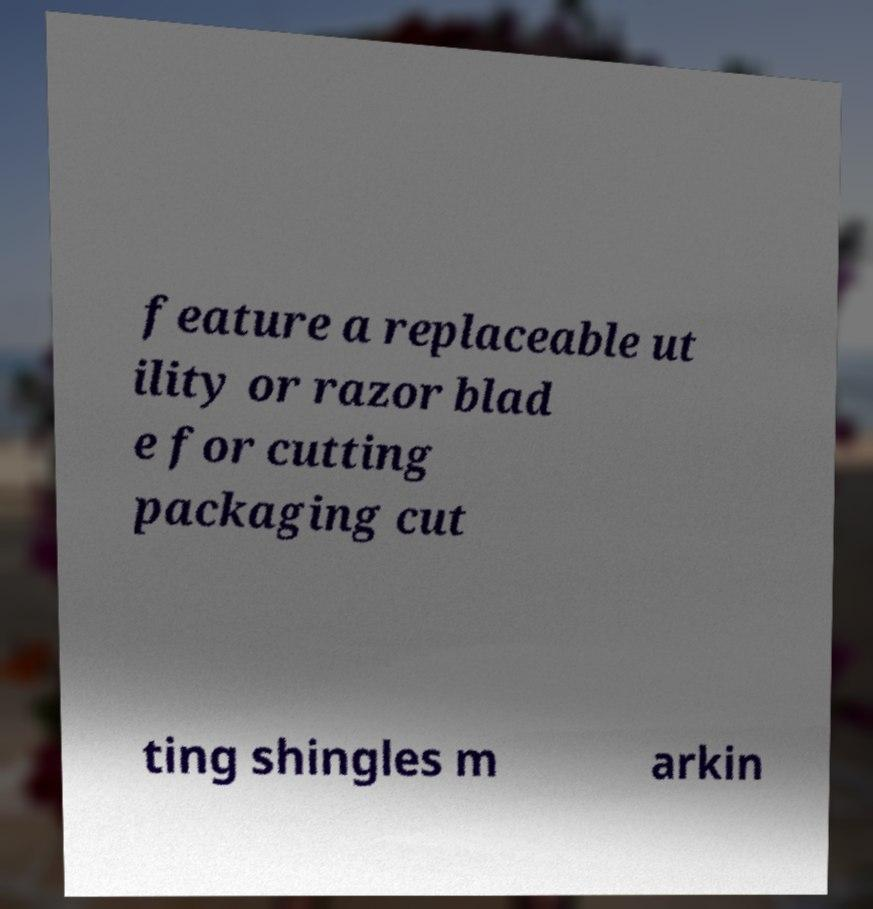There's text embedded in this image that I need extracted. Can you transcribe it verbatim? feature a replaceable ut ility or razor blad e for cutting packaging cut ting shingles m arkin 